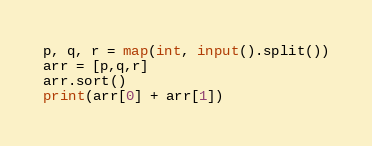<code> <loc_0><loc_0><loc_500><loc_500><_Python_>p, q, r = map(int, input().split())
arr = [p,q,r]
arr.sort()
print(arr[0] + arr[1])</code> 